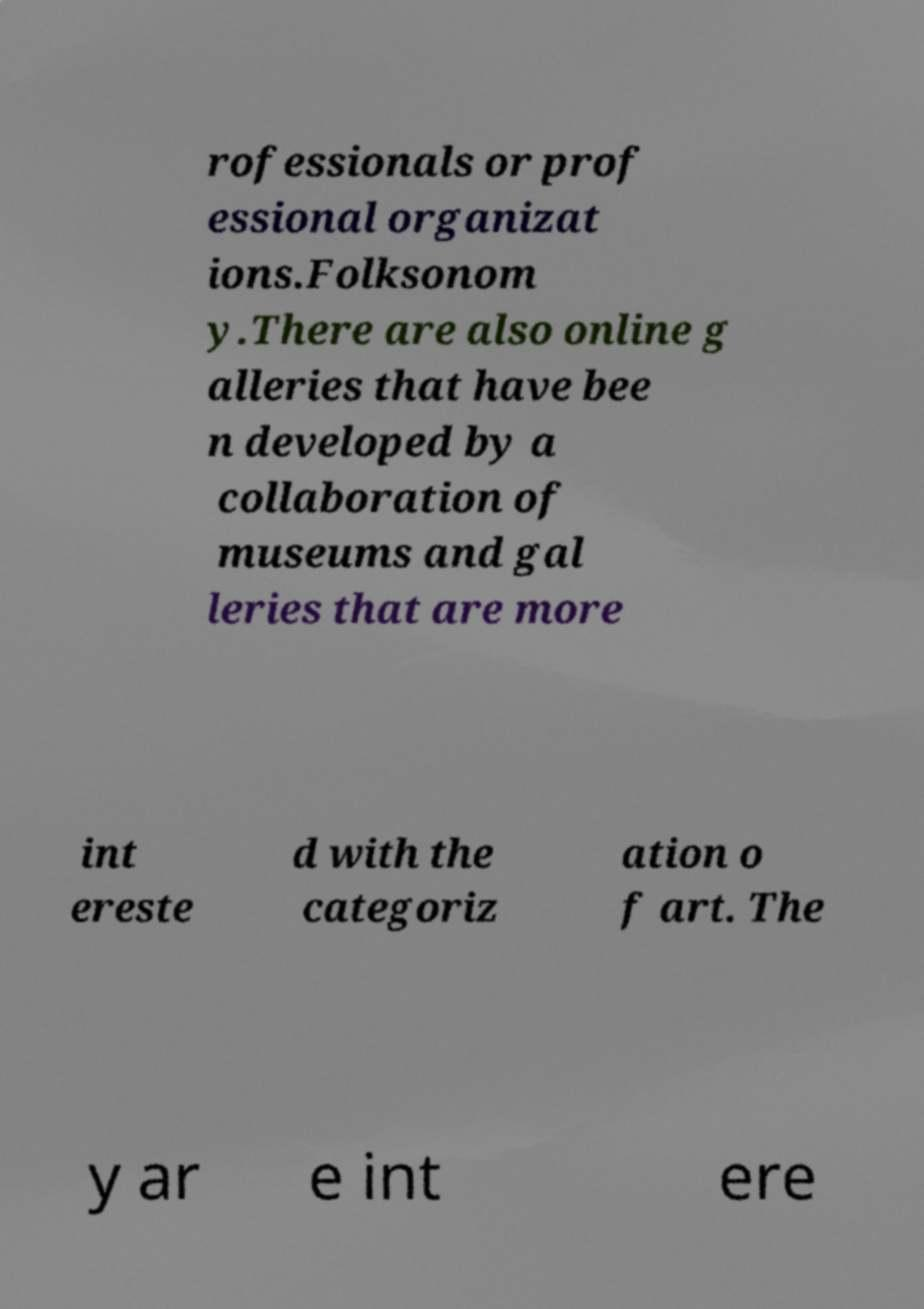Please identify and transcribe the text found in this image. rofessionals or prof essional organizat ions.Folksonom y.There are also online g alleries that have bee n developed by a collaboration of museums and gal leries that are more int ereste d with the categoriz ation o f art. The y ar e int ere 